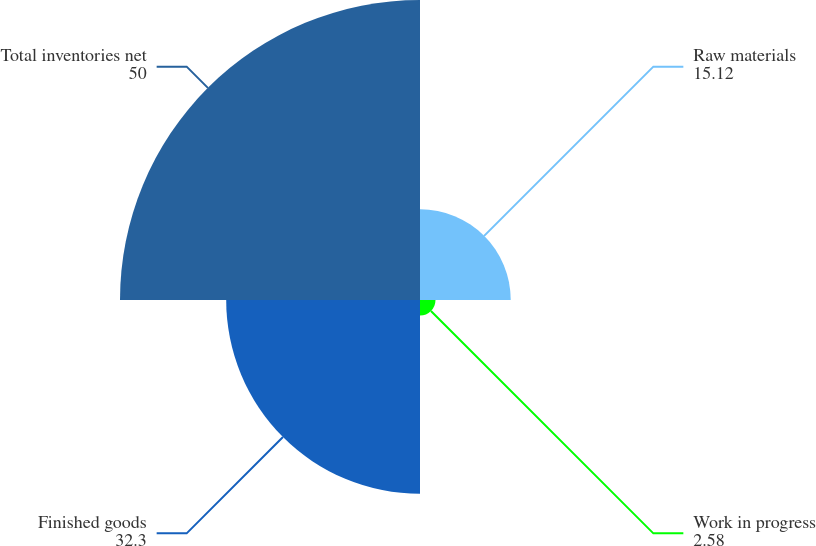<chart> <loc_0><loc_0><loc_500><loc_500><pie_chart><fcel>Raw materials<fcel>Work in progress<fcel>Finished goods<fcel>Total inventories net<nl><fcel>15.12%<fcel>2.58%<fcel>32.3%<fcel>50.0%<nl></chart> 